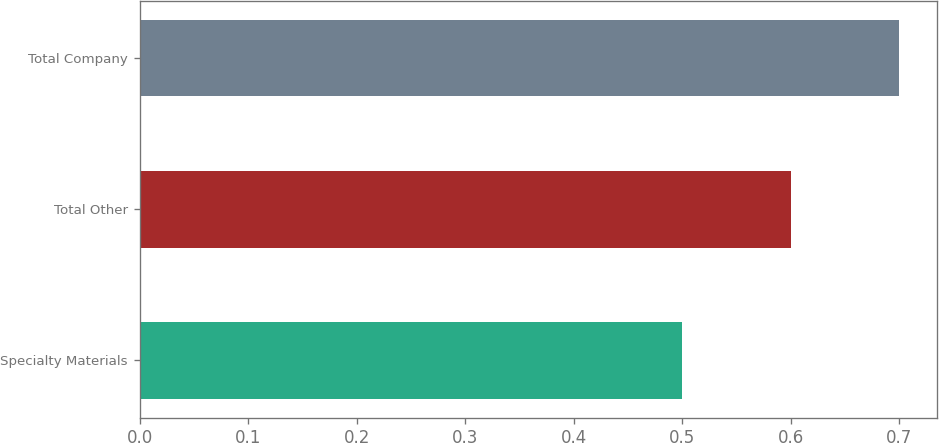Convert chart to OTSL. <chart><loc_0><loc_0><loc_500><loc_500><bar_chart><fcel>Specialty Materials<fcel>Total Other<fcel>Total Company<nl><fcel>0.5<fcel>0.6<fcel>0.7<nl></chart> 